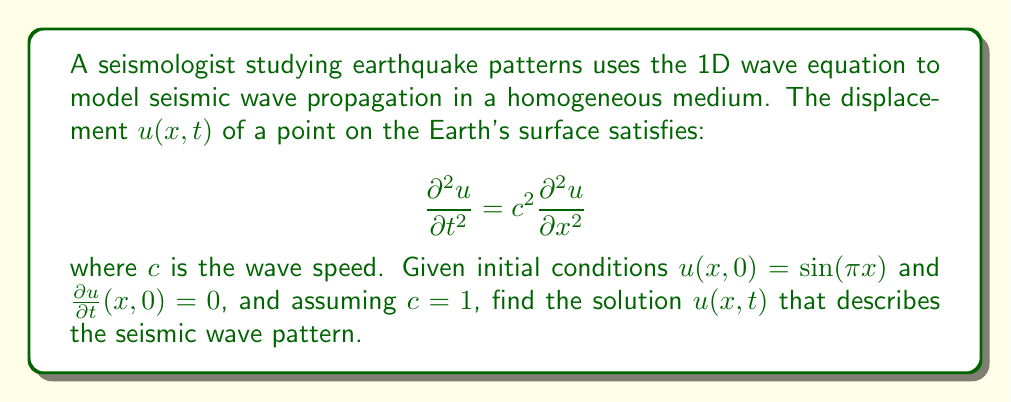Give your solution to this math problem. To solve this wave equation problem, we'll follow these steps:

1) The general solution for the 1D wave equation is of the form:
   $$u(x,t) = F(x-ct) + G(x+ct)$$

2) Given the initial conditions, we can use the method of separation of variables. Let's assume a solution of the form:
   $$u(x,t) = X(x)T(t)$$

3) Substituting this into the wave equation:
   $$X(x)T''(t) = c^2X''(x)T(t)$$

4) Dividing both sides by $c^2X(x)T(t)$:
   $$\frac{T''(t)}{c^2T(t)} = \frac{X''(x)}{X(x)} = -k^2$$

5) This gives us two ordinary differential equations:
   $$T''(t) + c^2k^2T(t) = 0$$
   $$X''(x) + k^2X(x) = 0$$

6) The solutions to these equations are:
   $$T(t) = A\cos(ckt) + B\sin(ckt)$$
   $$X(x) = C\sin(kx) + D\cos(kx)$$

7) From the initial condition $u(x,0) = \sin(\pi x)$, we can deduce:
   $$k = \pi, C = 1, D = 0$$

8) From $\frac{\partial u}{\partial t}(x,0) = 0$, we get $B = 0$

9) Therefore, our solution is of the form:
   $$u(x,t) = A\cos(\pi ct)\sin(\pi x)$$

10) To satisfy the initial condition $u(x,0) = \sin(\pi x)$, we must have $A = 1$

11) Given $c = 1$, our final solution is:
    $$u(x,t) = \cos(\pi t)\sin(\pi x)$$

This solution represents a standing wave pattern, which is typical for seismic waves in a confined medium.
Answer: $u(x,t) = \cos(\pi t)\sin(\pi x)$ 